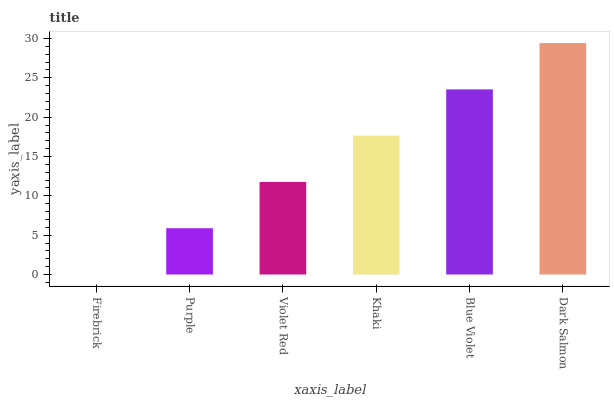Is Firebrick the minimum?
Answer yes or no. Yes. Is Dark Salmon the maximum?
Answer yes or no. Yes. Is Purple the minimum?
Answer yes or no. No. Is Purple the maximum?
Answer yes or no. No. Is Purple greater than Firebrick?
Answer yes or no. Yes. Is Firebrick less than Purple?
Answer yes or no. Yes. Is Firebrick greater than Purple?
Answer yes or no. No. Is Purple less than Firebrick?
Answer yes or no. No. Is Khaki the high median?
Answer yes or no. Yes. Is Violet Red the low median?
Answer yes or no. Yes. Is Firebrick the high median?
Answer yes or no. No. Is Blue Violet the low median?
Answer yes or no. No. 